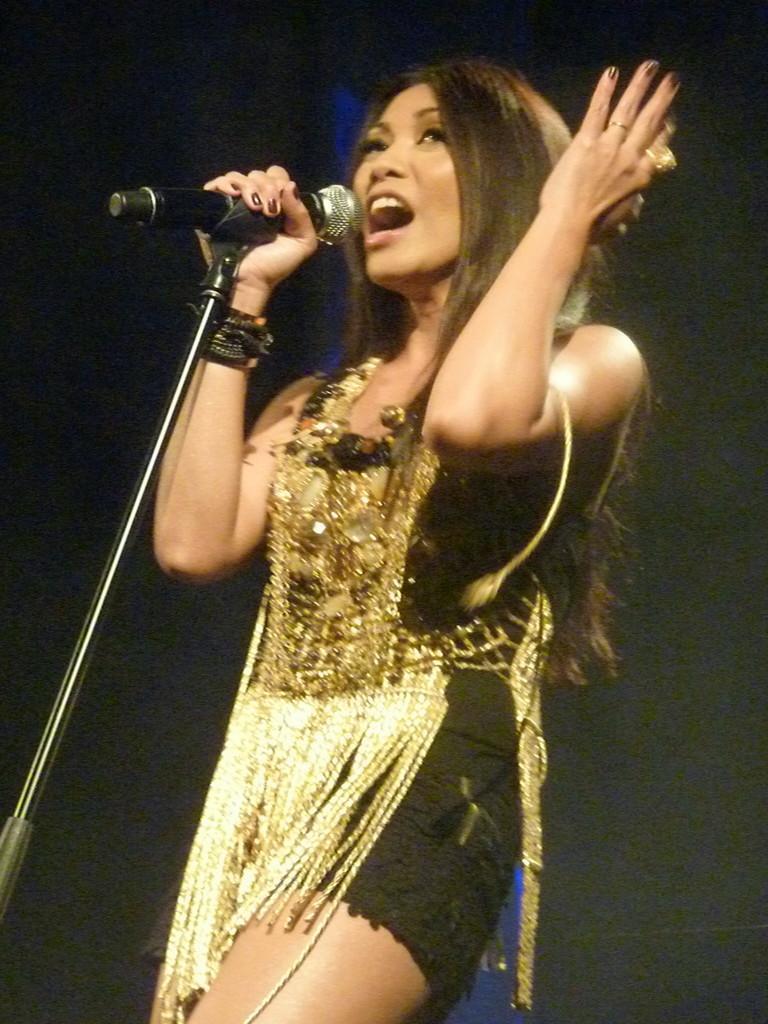Describe this image in one or two sentences. In this image there is a woman standing and singing. She is wearing a black and golden color dress. She is holding a mic along with mic stand. The background is too dark. 